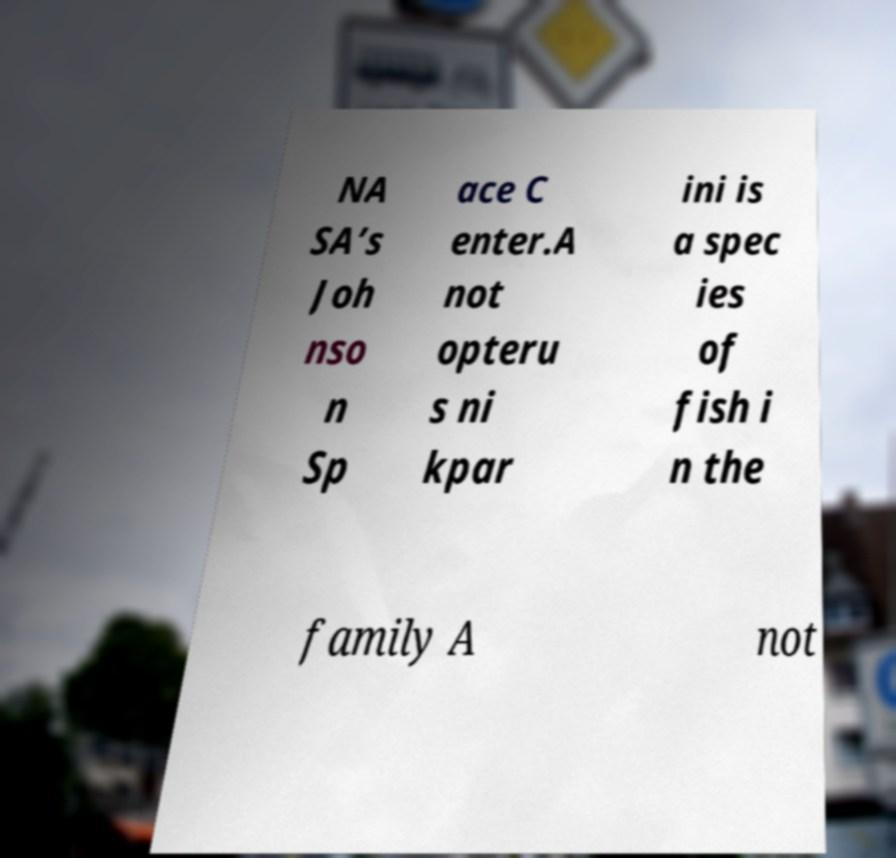Could you extract and type out the text from this image? NA SA’s Joh nso n Sp ace C enter.A not opteru s ni kpar ini is a spec ies of fish i n the family A not 